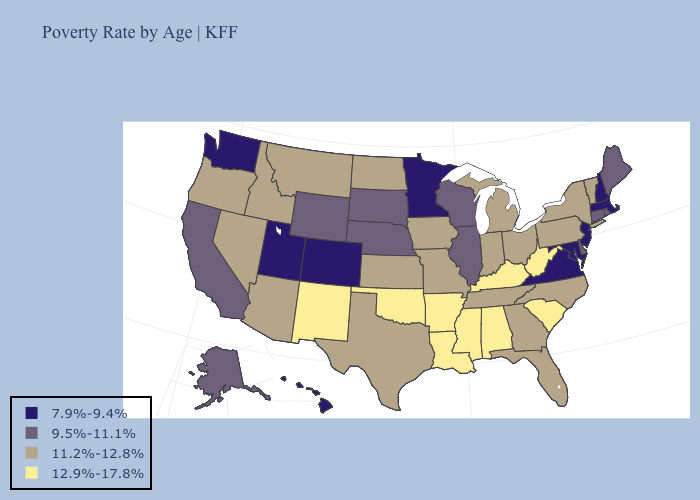Name the states that have a value in the range 9.5%-11.1%?
Give a very brief answer. Alaska, California, Connecticut, Delaware, Illinois, Maine, Nebraska, Rhode Island, South Dakota, Wisconsin, Wyoming. Does South Carolina have the highest value in the USA?
Quick response, please. Yes. What is the lowest value in the West?
Be succinct. 7.9%-9.4%. Among the states that border Oregon , does Idaho have the highest value?
Give a very brief answer. Yes. What is the lowest value in states that border Pennsylvania?
Keep it brief. 7.9%-9.4%. Name the states that have a value in the range 12.9%-17.8%?
Be succinct. Alabama, Arkansas, Kentucky, Louisiana, Mississippi, New Mexico, Oklahoma, South Carolina, West Virginia. Does Kansas have the highest value in the USA?
Keep it brief. No. Among the states that border Maryland , which have the lowest value?
Short answer required. Virginia. Does Wyoming have the lowest value in the USA?
Be succinct. No. Does the first symbol in the legend represent the smallest category?
Be succinct. Yes. What is the lowest value in the USA?
Answer briefly. 7.9%-9.4%. What is the highest value in the South ?
Be succinct. 12.9%-17.8%. What is the value of Nevada?
Be succinct. 11.2%-12.8%. Among the states that border Minnesota , does South Dakota have the lowest value?
Write a very short answer. Yes. Among the states that border Mississippi , which have the highest value?
Answer briefly. Alabama, Arkansas, Louisiana. 